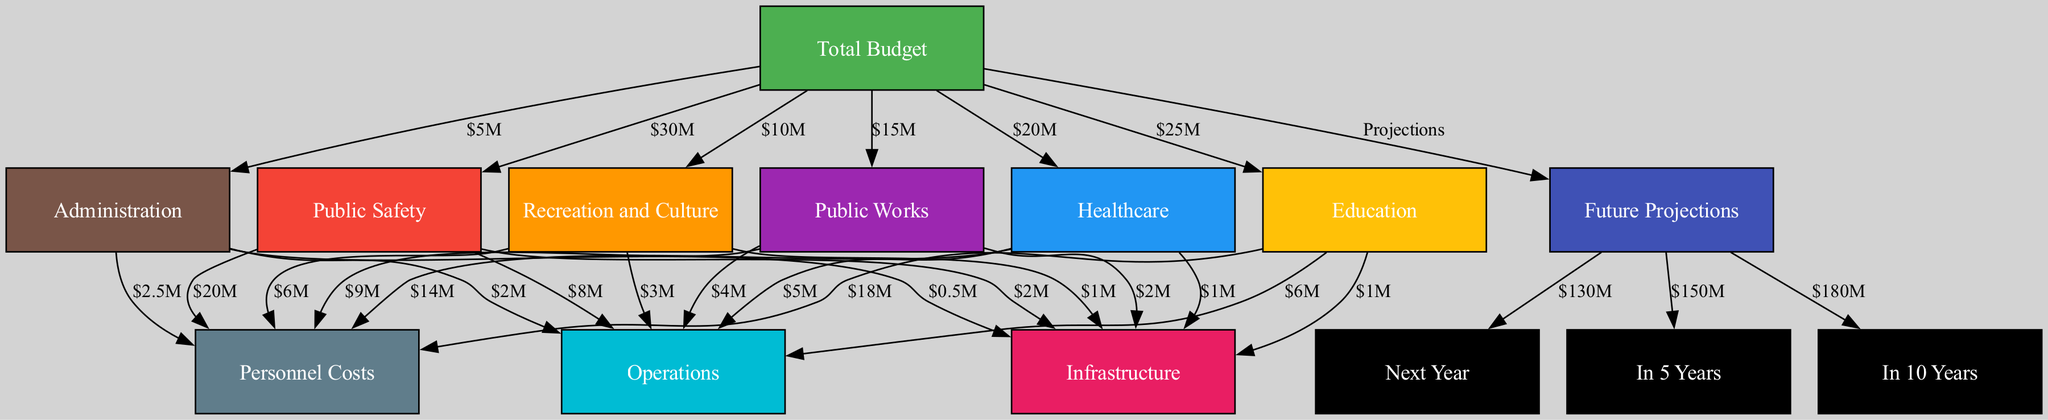What is the total budget allocation for Sand Creek city departments? The total budget is represented as the top-level node in the diagram, directly stating the overall budget figure for all departments. It is clearly labeled and shown as $130 million.
Answer: $130 million How much is allocated to public safety? The public safety node provides a direct link from the total budget, showing its specific allocation. The label on this edge indicates that public safety has an allocation of $30 million.
Answer: $30 million What percentage of the total budget is allocated to healthcare? The allocation for healthcare is $20 million, which is a part of the total budget of $130 million. To find the percentage, we calculate (20/130)*100, which simplifies to approximately 15.38%.
Answer: 15.38% Which department has the highest personnel costs? By reviewing the expenditures listed under each department, I see that public safety has the highest personnel costs of $20 million. This is the highest of all the personnel costs listed under each department node.
Answer: Public Safety What is the total amount allocated for education and public works combined? The allocations for education and public works are $25 million and $15 million, respectively. Adding these two amounts together gives us $25 million + $15 million = $40 million.
Answer: $40 million How much is projected for the budget in 10 years? Looking at the future projections section of the diagram, the amount allocated for the budget in 10 years is specified as $180 million. This node is directly connected to future projections indicating its value clearly.
Answer: $180 million Which department has the least allocation for operations? The operations expenditure across departments shows that public safety has the least allocation, with only $2 million as indicated in the operations breakdown of the public safety node.
Answer: Public Safety What is the total allocated for recreation and culture, including personnel costs and operations? The recreation and culture allocation is $10 million for the overall department. The personnel costs for this department total $6 million, and operations are $3 million. Adding these amounts together gives us $10 million + $6 million + $3 million = $19 million.
Answer: $19 million How many departments are allocated expenditures from the total budget? By counting the nodes directly connected to the total budget node, we see there are six departments represented: public safety, healthcare, education, public works, recreation and culture, and administration. Thus, there are six departments that receive budget allocations.
Answer: Six 